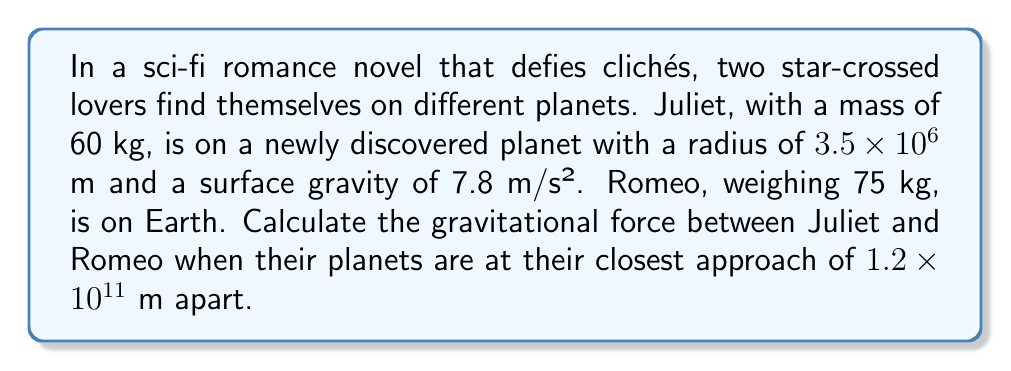Can you answer this question? To solve this unique problem, we'll follow these steps:

1) First, we need to determine the mass of Juliet's planet. We can do this using the surface gravity equation:

   $g = \frac{GM}{R^2}$

   Where $g$ is surface gravity, $G$ is the gravitational constant ($6.67 \times 10^{-11}$ N⋅m²/kg²), $M$ is the planet's mass, and $R$ is the planet's radius.

2) Rearranging the equation and solving for $M$:

   $M = \frac{gR^2}{G}$
   $M = \frac{7.8 \times (3.5 \times 10^6)^2}{6.67 \times 10^{-11}} = 1.42 \times 10^{24}$ kg

3) Now we know the masses involved:
   - Juliet's mass: $m_J = 60$ kg
   - Romeo's mass: $m_R = 75$ kg
   - Juliet's planet mass: $M_J = 1.42 \times 10^{24}$ kg
   - Earth's mass: $M_E = 5.97 \times 10^{24}$ kg

4) The gravitational force between two objects is given by:

   $F = G\frac{m_1m_2}{r^2}$

   Where $r$ is the distance between the objects.

5) In this case, we need to consider the total mass of each system:
   - System 1: Juliet + her planet
   - System 2: Romeo + Earth

6) Plugging in the values:

   $F = 6.67 \times 10^{-11} \times \frac{(60 + 1.42 \times 10^{24})(75 + 5.97 \times 10^{24})}{(1.2 \times 10^{11})^2}$

7) Simplifying:

   $F = 6.67 \times 10^{-11} \times \frac{1.42 \times 10^{24} \times 5.97 \times 10^{24}}{1.44 \times 10^{22}}$

8) Calculating the final result:

   $F = 3.94 \times 10^{13}$ N
Answer: $3.94 \times 10^{13}$ N 